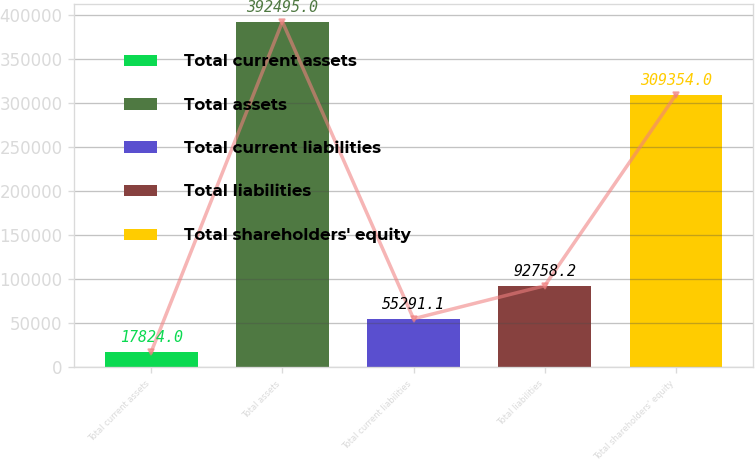Convert chart. <chart><loc_0><loc_0><loc_500><loc_500><bar_chart><fcel>Total current assets<fcel>Total assets<fcel>Total current liabilities<fcel>Total liabilities<fcel>Total shareholders' equity<nl><fcel>17824<fcel>392495<fcel>55291.1<fcel>92758.2<fcel>309354<nl></chart> 